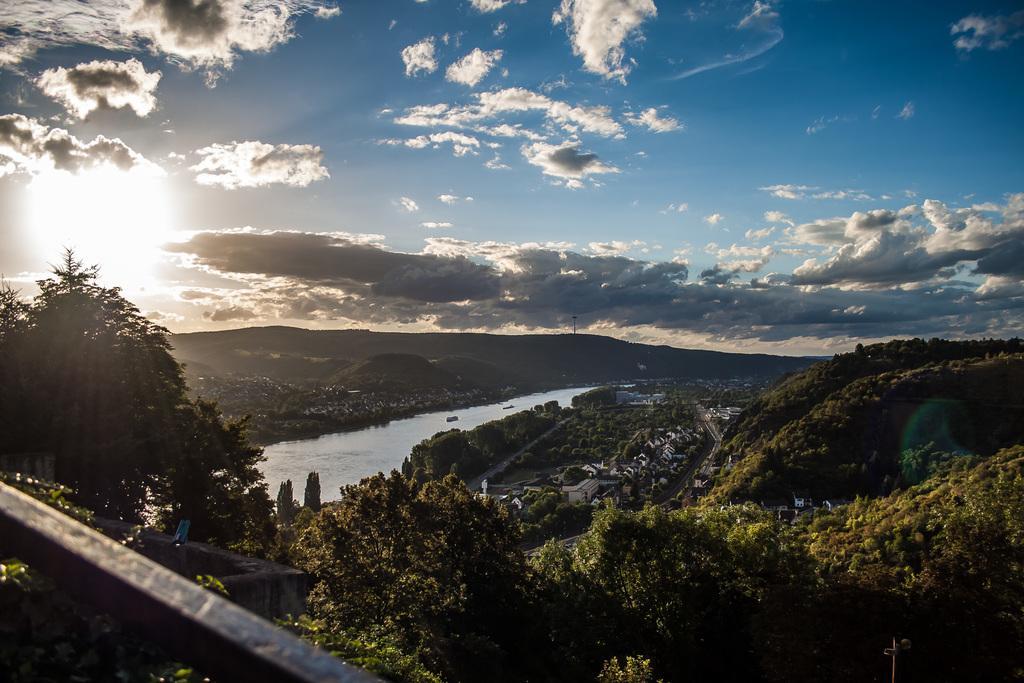How would you summarize this image in a sentence or two? In the center of the image there is water. There are trees,buildings,mountains. In the background of the image there is sky,clouds,sun. 